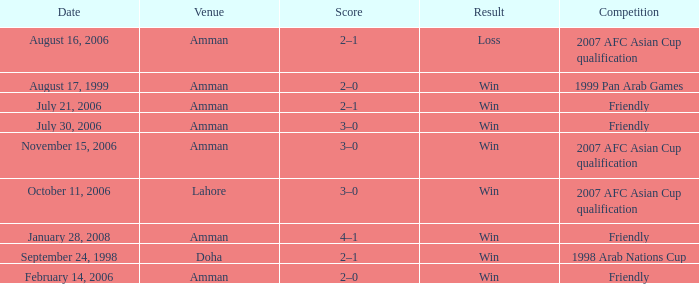What was the score of the friendly match at Amman on February 14, 2006? 2–0. 